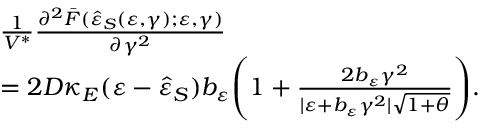<formula> <loc_0><loc_0><loc_500><loc_500>\begin{array} { r l } & { \frac { 1 } { V ^ { \ast } } \frac { \partial ^ { 2 } \bar { F } ( \hat { \varepsilon } _ { S } ( \varepsilon , \gamma ) ; \varepsilon , \gamma ) } { \partial \gamma ^ { 2 } } } \\ & { = 2 D \kappa _ { E } ( \varepsilon - \hat { \varepsilon } _ { S } ) b _ { \varepsilon } \left ( 1 + \frac { 2 b _ { \varepsilon } \gamma ^ { 2 } } { | \varepsilon + b _ { \varepsilon } \gamma ^ { 2 } | \sqrt { 1 + \theta } } \right ) . } \end{array}</formula> 